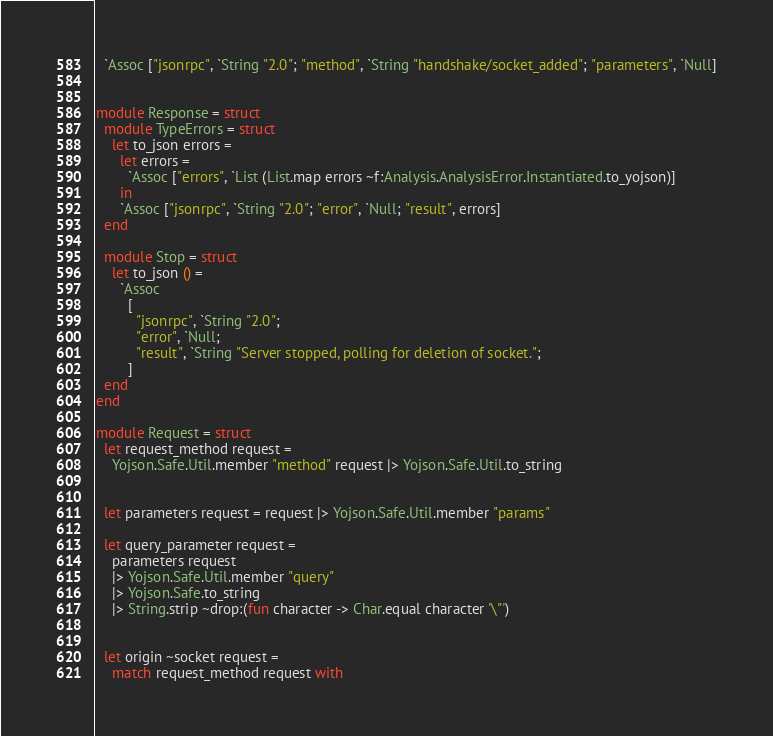<code> <loc_0><loc_0><loc_500><loc_500><_OCaml_>  `Assoc ["jsonrpc", `String "2.0"; "method", `String "handshake/socket_added"; "parameters", `Null]


module Response = struct
  module TypeErrors = struct
    let to_json errors =
      let errors =
        `Assoc ["errors", `List (List.map errors ~f:Analysis.AnalysisError.Instantiated.to_yojson)]
      in
      `Assoc ["jsonrpc", `String "2.0"; "error", `Null; "result", errors]
  end

  module Stop = struct
    let to_json () =
      `Assoc
        [
          "jsonrpc", `String "2.0";
          "error", `Null;
          "result", `String "Server stopped, polling for deletion of socket.";
        ]
  end
end

module Request = struct
  let request_method request =
    Yojson.Safe.Util.member "method" request |> Yojson.Safe.Util.to_string


  let parameters request = request |> Yojson.Safe.Util.member "params"

  let query_parameter request =
    parameters request
    |> Yojson.Safe.Util.member "query"
    |> Yojson.Safe.to_string
    |> String.strip ~drop:(fun character -> Char.equal character '\"')


  let origin ~socket request =
    match request_method request with</code> 